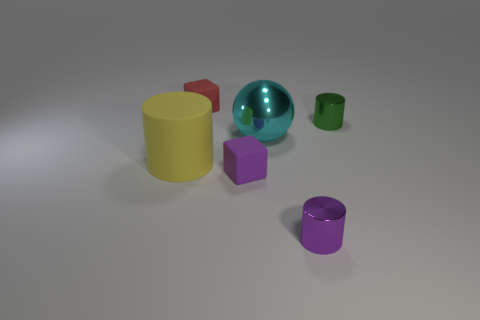Is the number of big yellow objects greater than the number of large brown spheres?
Offer a very short reply. Yes. There is a small metal object that is behind the cyan metallic thing; is it the same shape as the yellow thing?
Provide a succinct answer. Yes. How many rubber things are balls or green things?
Ensure brevity in your answer.  0. Are there any balls that have the same material as the red block?
Ensure brevity in your answer.  No. What is the red thing made of?
Offer a terse response. Rubber. What shape is the tiny rubber thing that is on the right side of the tiny rubber cube behind the metallic cylinder that is on the right side of the small purple metal cylinder?
Provide a short and direct response. Cube. Is the number of small purple metal cylinders that are behind the red cube greater than the number of small green objects?
Offer a terse response. No. Is the shape of the big yellow rubber object the same as the large object behind the yellow matte cylinder?
Your answer should be very brief. No. How many small rubber objects are on the right side of the tiny object that is on the left side of the cube that is in front of the red rubber block?
Offer a very short reply. 1. What color is the other shiny cylinder that is the same size as the green shiny cylinder?
Ensure brevity in your answer.  Purple. 